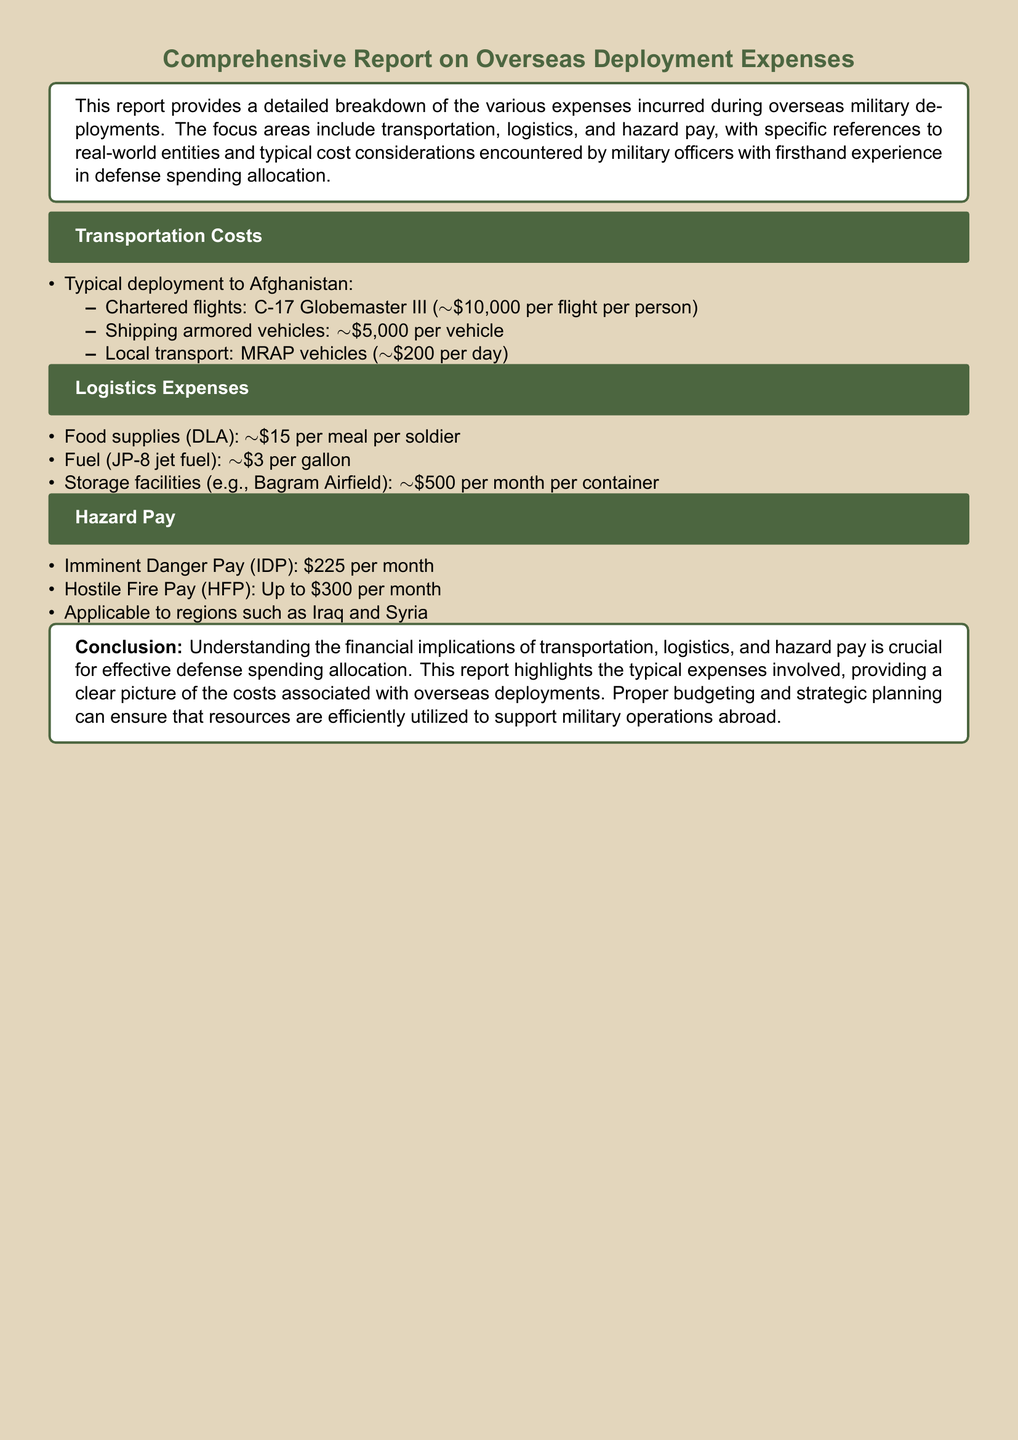What is the cost of a chartered flight to Afghanistan? The cost of a chartered flight to Afghanistan on a C-17 Globemaster III is approximately $10,000 per flight per person.
Answer: $10,000 per flight per person What is the cost of shipping an armored vehicle? The document states that the cost for shipping an armored vehicle is approximately $5,000 per vehicle.
Answer: $5,000 per vehicle What is the daily transport cost for MRAP vehicles? The local transport cost for MRAP vehicles is approximately $200 per day.
Answer: $200 per day What is the cost of food supplies per meal per soldier? Food supplies (DLA) cost approximately $15 per meal per soldier.
Answer: $15 per meal per soldier What is the cost of storing a container per month at Bagram Airfield? The cost of storage facilities at Bagram Airfield is approximately $500 per month per container.
Answer: $500 per month What is Imminent Danger Pay (IDP)? Imminent Danger Pay, or IDP, is established at $225 per month.
Answer: $225 per month Which regions are applicable for Hazard Pay? The regions mentioned for Hazard Pay application include Iraq and Syria.
Answer: Iraq and Syria What is the maximum amount for Hostile Fire Pay (HFP)? Hostile Fire Pay (HFP) can go up to $300 per month.
Answer: $300 per month What are the key areas covered in this report? The report focuses on transportation, logistics, and hazard pay as key areas.
Answer: Transportation, logistics, and hazard pay 